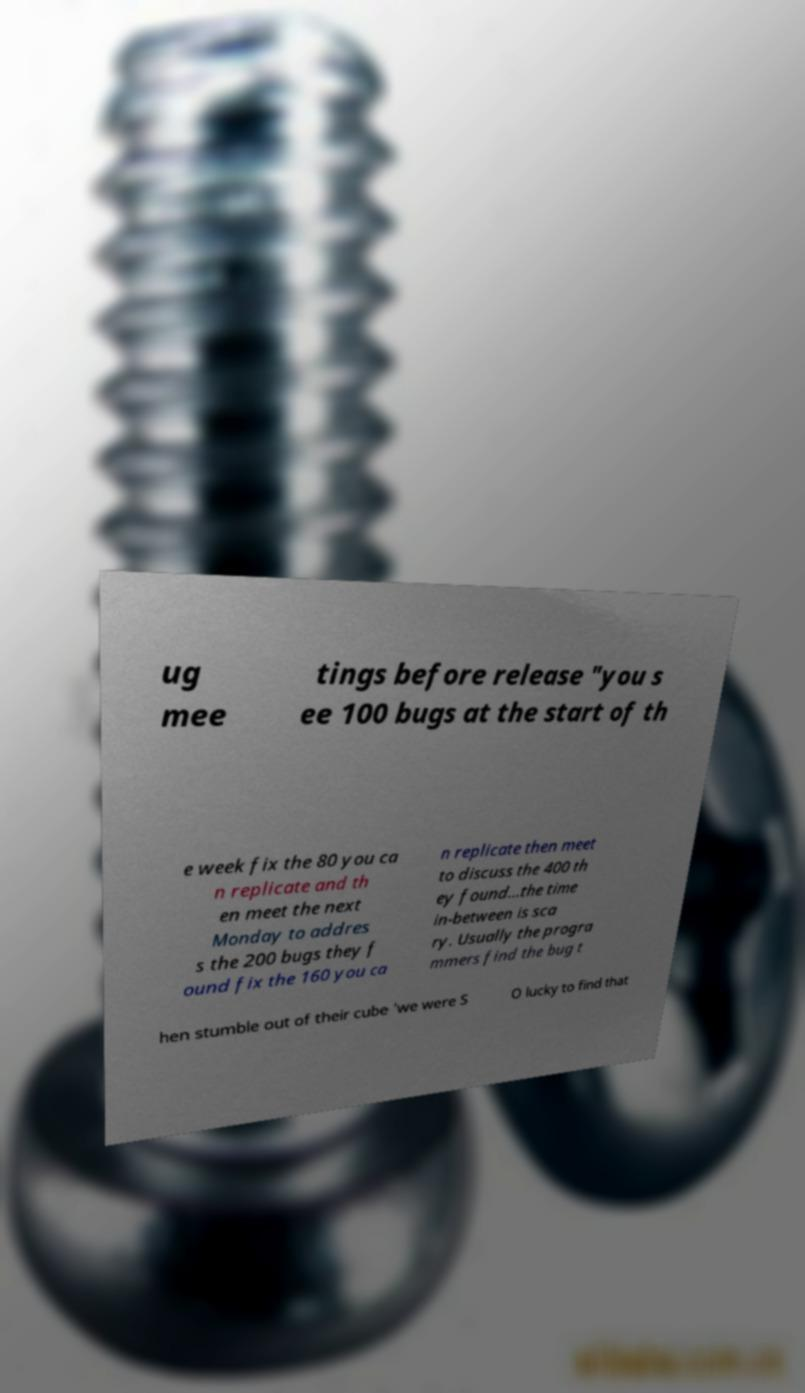Please read and relay the text visible in this image. What does it say? ug mee tings before release "you s ee 100 bugs at the start of th e week fix the 80 you ca n replicate and th en meet the next Monday to addres s the 200 bugs they f ound fix the 160 you ca n replicate then meet to discuss the 400 th ey found...the time in-between is sca ry. Usually the progra mmers find the bug t hen stumble out of their cube 'we were S O lucky to find that 